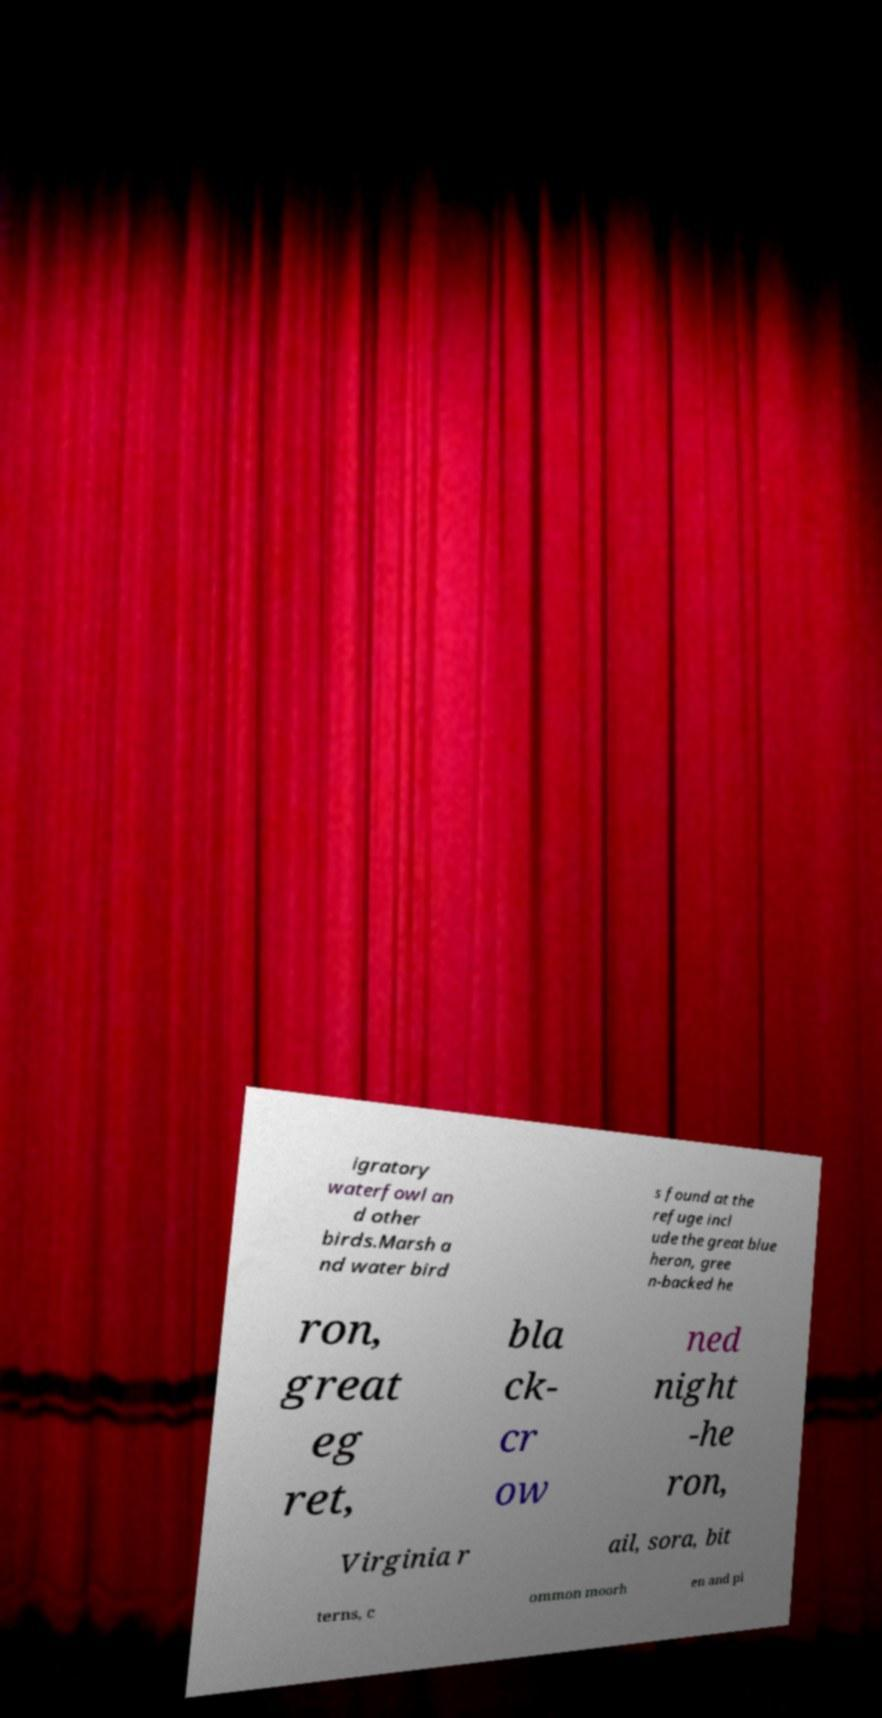I need the written content from this picture converted into text. Can you do that? igratory waterfowl an d other birds.Marsh a nd water bird s found at the refuge incl ude the great blue heron, gree n-backed he ron, great eg ret, bla ck- cr ow ned night -he ron, Virginia r ail, sora, bit terns, c ommon moorh en and pi 